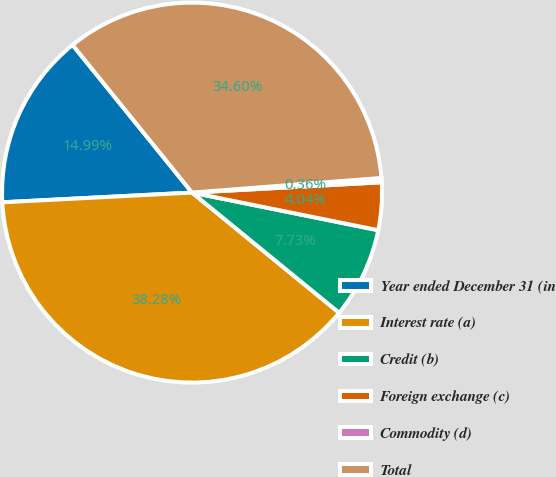<chart> <loc_0><loc_0><loc_500><loc_500><pie_chart><fcel>Year ended December 31 (in<fcel>Interest rate (a)<fcel>Credit (b)<fcel>Foreign exchange (c)<fcel>Commodity (d)<fcel>Total<nl><fcel>14.99%<fcel>38.28%<fcel>7.73%<fcel>4.04%<fcel>0.36%<fcel>34.6%<nl></chart> 